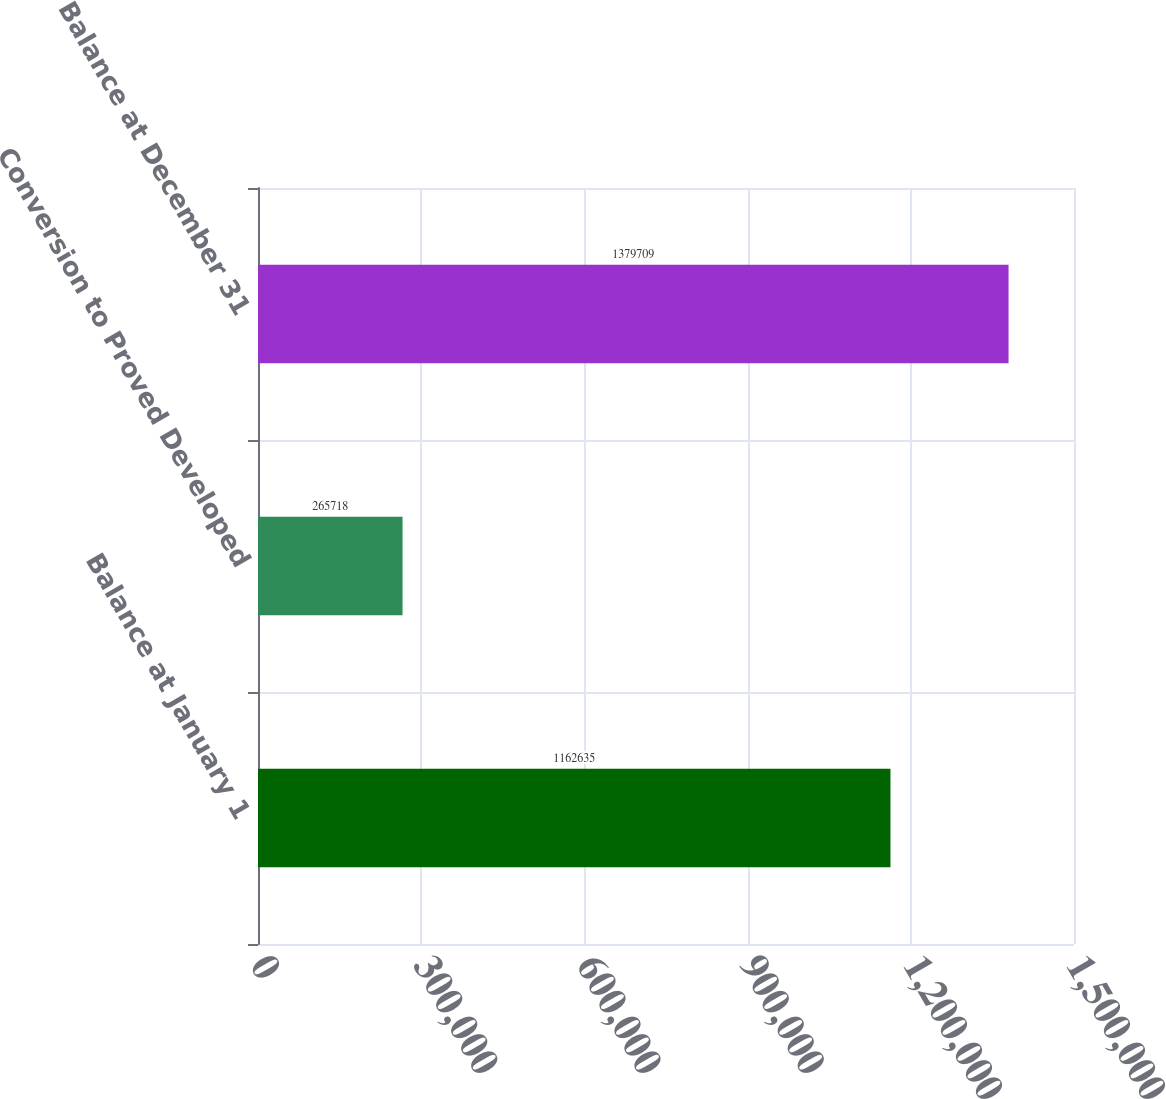<chart> <loc_0><loc_0><loc_500><loc_500><bar_chart><fcel>Balance at January 1<fcel>Conversion to Proved Developed<fcel>Balance at December 31<nl><fcel>1.16264e+06<fcel>265718<fcel>1.37971e+06<nl></chart> 